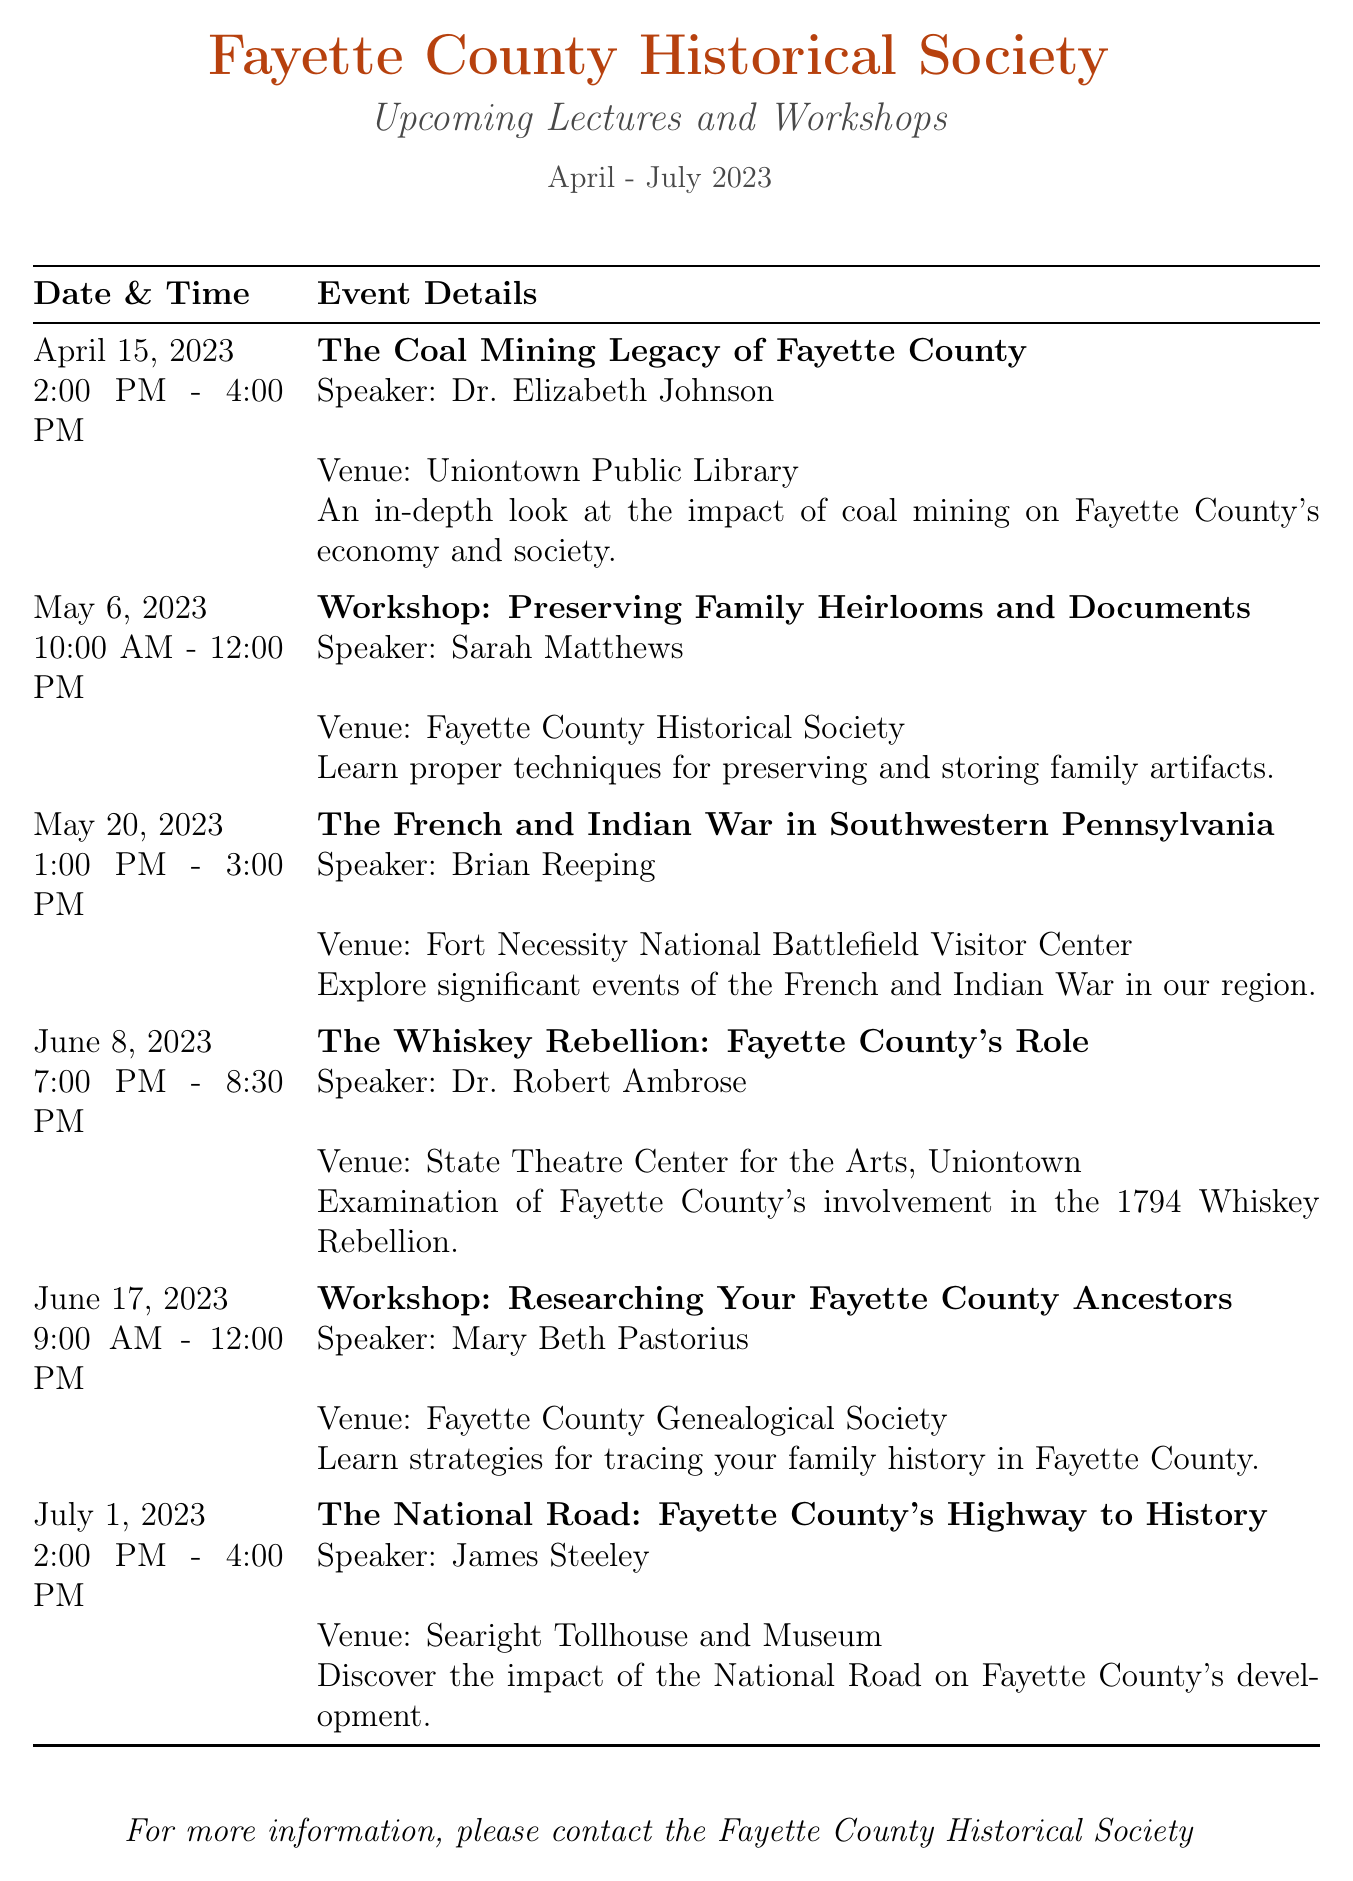What is the title of the first lecture? The title of the first lecture is found in the first event details section, which states it is about coal mining in Fayette County.
Answer: The Coal Mining Legacy of Fayette County Who is the speaker for the workshop on preserving family heirlooms? The speaker for the workshop is mentioned alongside the event details, focusing on preserving family items.
Answer: Sarah Matthews What date is the lecture on the French and Indian War scheduled? The lecture date is indicated in the second event details, specifically referring to a historical conflict in Southwestern Pennsylvania.
Answer: May 20, 2023 What is the duration of the Whiskey Rebellion lecture? The duration is mentioned in the event details for this lecture, specifying the starting and ending times.
Answer: 1 hour 30 minutes Where will the National Road lecture take place? The venue for the National Road lecture is specified in the event details section, noting its historical importance.
Answer: Searight Tollhouse and Museum How many workshops are scheduled in total? The total number of workshops is extracted by counting the number of workshop entries in the document.
Answer: 2 Which speaker is associated with the French and Indian War lecture? The speaker is associated with the event details of the French and Indian War lecture in the document.
Answer: Brian Reeping What time does the first session on June 17 start? The start time is indicated in the event details for the workshop on researching ancestors.
Answer: 9:00 AM 